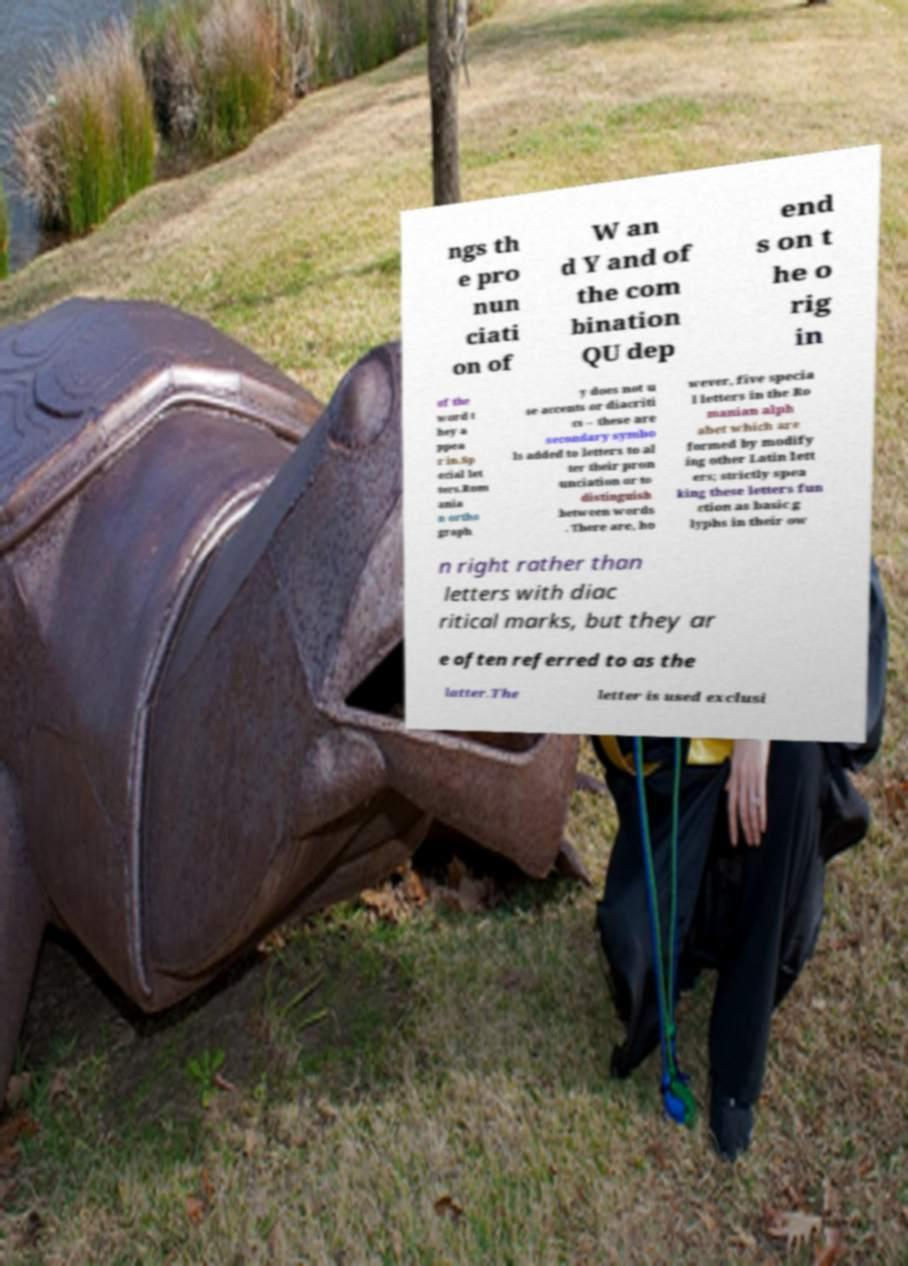Please identify and transcribe the text found in this image. ngs th e pro nun ciati on of W an d Y and of the com bination QU dep end s on t he o rig in of the word t hey a ppea r in.Sp ecial let ters.Rom ania n ortho graph y does not u se accents or diacriti cs – these are secondary symbo ls added to letters to al ter their pron unciation or to distinguish between words . There are, ho wever, five specia l letters in the Ro manian alph abet which are formed by modify ing other Latin lett ers; strictly spea king these letters fun ction as basic g lyphs in their ow n right rather than letters with diac ritical marks, but they ar e often referred to as the latter.The letter is used exclusi 